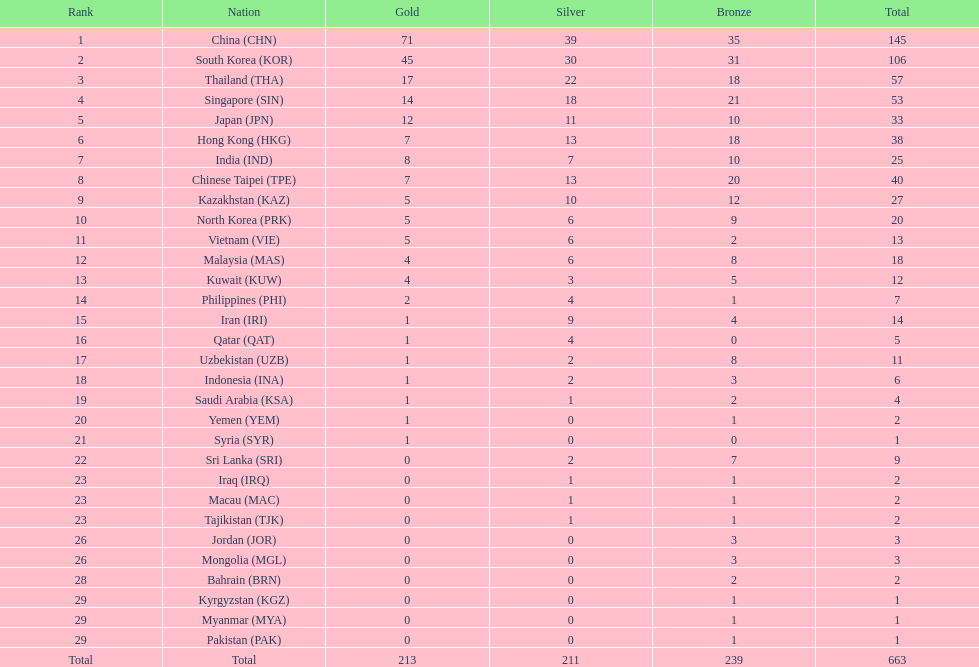How many nations secured at least ten bronze awards? 9. 